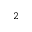<formula> <loc_0><loc_0><loc_500><loc_500>^ { 2 }</formula> 